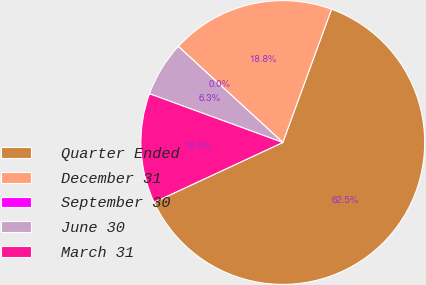<chart> <loc_0><loc_0><loc_500><loc_500><pie_chart><fcel>Quarter Ended<fcel>December 31<fcel>September 30<fcel>June 30<fcel>March 31<nl><fcel>62.49%<fcel>18.75%<fcel>0.0%<fcel>6.25%<fcel>12.5%<nl></chart> 